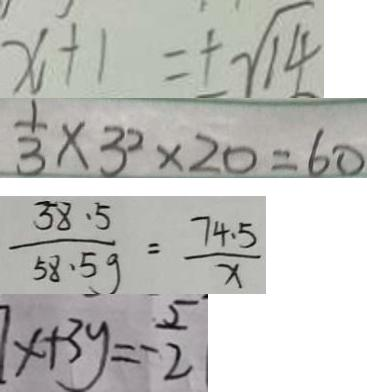<formula> <loc_0><loc_0><loc_500><loc_500>x + 1 = \pm \sqrt { 1 4 } 
 \frac { 1 } { 3 } \times 3 ^ { 2 } \times 2 0 = 6 0 
 \frac { 3 8 . 5 } { 5 8 . 5 g } = \frac { 7 4 . 5 } { x } 
 x + 3 y = - \frac { 5 } { 2 }</formula> 